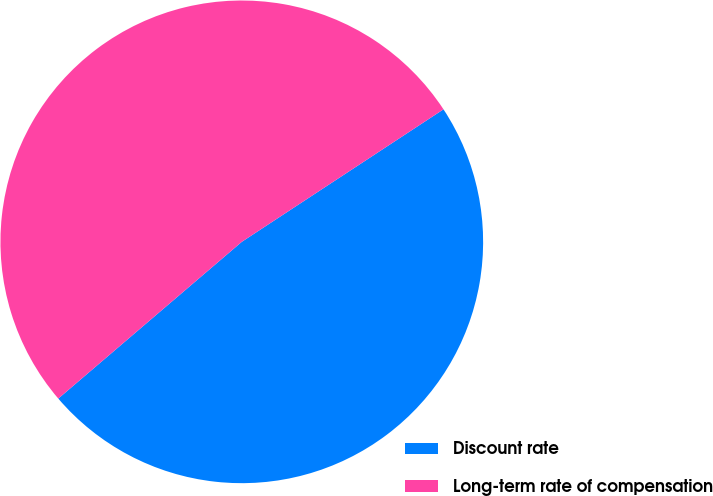<chart> <loc_0><loc_0><loc_500><loc_500><pie_chart><fcel>Discount rate<fcel>Long-term rate of compensation<nl><fcel>48.0%<fcel>52.0%<nl></chart> 